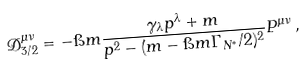<formula> <loc_0><loc_0><loc_500><loc_500>\mathcal { D } _ { 3 / 2 } ^ { \mu \nu } = - \i m \frac { \gamma _ { \lambda } p ^ { \lambda } + m } { p ^ { 2 } - ( m - \i m \Gamma _ { N ^ { * } } / 2 ) ^ { 2 } } P ^ { \mu \nu } \, ,</formula> 